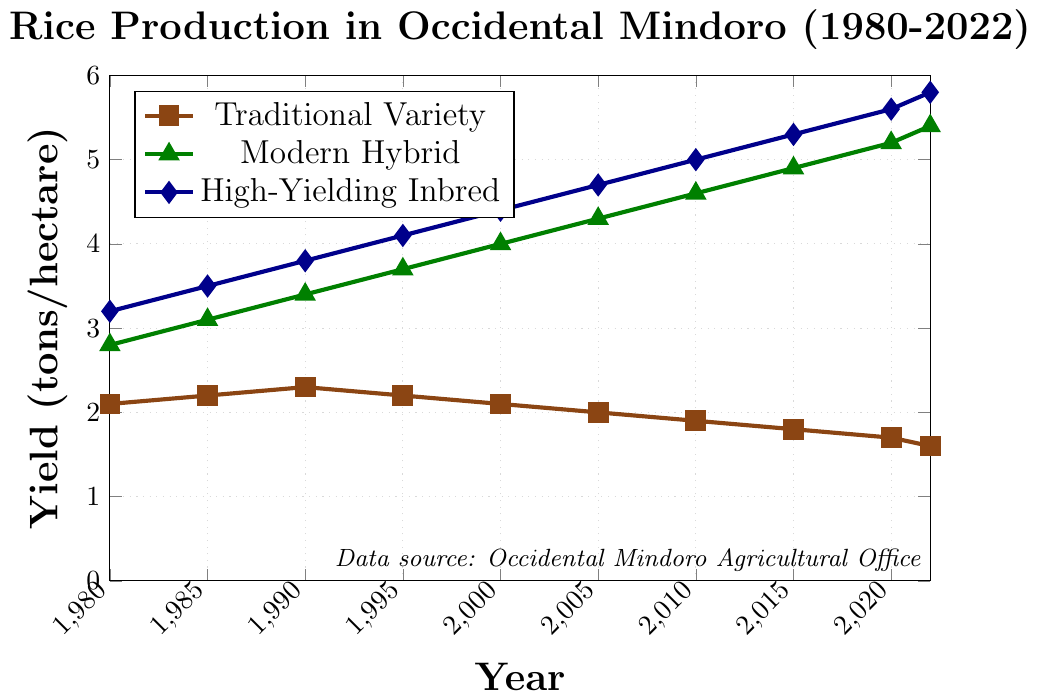What's the yield of the High-Yielding Inbred variety in 1995? Refer to the highlighted point on the High-Yielding Inbred line for the year 1995, which indicates the yield value.
Answer: 4.1 tons/hectare How much did the Modern Hybrid variety increase from 1980 to 2022? Find the yield values for Modern Hybrid in 1980 and 2022, then subtract the earlier value from the later one: 5.4 - 2.8.
Answer: 2.6 tons/hectare Which variety had the highest yield increase from 1980 to 2022? Calculate the increase for each variety: Traditional Variety (1.6 - 2.1 = -0.5), Modern Hybrid (5.4 - 2.8 = 2.6), High-Yielding Inbred (5.8 - 3.2 = 2.6). Compare the increases, noting High-Yielding Inbred and Modern Hybrid both have the same highest increase.
Answer: High-Yielding Inbred and Modern Hybrid What is the average yield of the Traditional Variety from 1980 to 2022? Sum the yields of Traditional Variety over all the years and divide by the number of years: (2.1 + 2.2 + 2.3 + 2.2 + 2.1 + 2.0 + 1.9 + 1.8 + 1.7 + 1.6) / 10.
Answer: 2.0 tons/hectare Between which consecutive years did the High-Yielding Inbred variety show the largest increase in yield? Find the difference between each consecutive pair of years for High-Yielding Inbred: 1985-1980 (3.5-3.2=0.3), 1990-1985 (3.8-3.5=0.3), 1995-1990 (4.1-3.8=0.3), 2000-1995 (4.4-4.1=0.3), 2005-2000 (4.7-4.4=0.3), 2010-2005 (5.0-4.7=0.3), 2015-2010 (5.3-5.0=0.3), 2020-2015 (5.6-5.3=0.3), 2022-2020 (5.8-5.6=0.2). The largest increase is 0.3, which occurs multiple times. Any period with this increase can be a correct answer.
Answer: Multiple 5-year periods Which variety had a declining trend in yield over the years? Observe the lines: the Traditional Variety clearly shows a consistent decline from 1980 to 2022.
Answer: Traditional Variety In what year did the Modern Hybrid variety surpass a yield of 4 tons/hectare? Find the first year where the value for Modern Hybrid is above 4: 2000 shows a yield of 4.0, so the year after that, 2005, will be the answer.
Answer: 2005 How much higher was the yield of the High-Yielding Inbred variety compared to the Traditional Variety in 1980? Subtract the yield of Traditional Variety from the yield of High-Yielding Inbred for 1980: 3.2 - 2.1.
Answer: 1.1 tons/hectare 